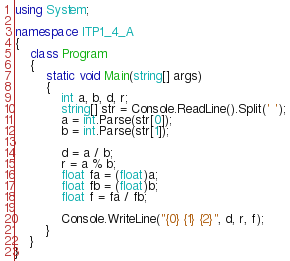<code> <loc_0><loc_0><loc_500><loc_500><_C#_>using System;

namespace ITP1_4_A
{
    class Program
    {
        static void Main(string[] args)
        {
            int a, b, d, r;
            string[] str = Console.ReadLine().Split(' ');
            a = int.Parse(str[0]);
            b = int.Parse(str[1]);

            d = a / b;
            r = a % b;
            float fa = (float)a;
            float fb = (float)b;
            float f = fa / fb;

            Console.WriteLine("{0} {1} {2}", d, r, f);
        }
    }
}</code> 